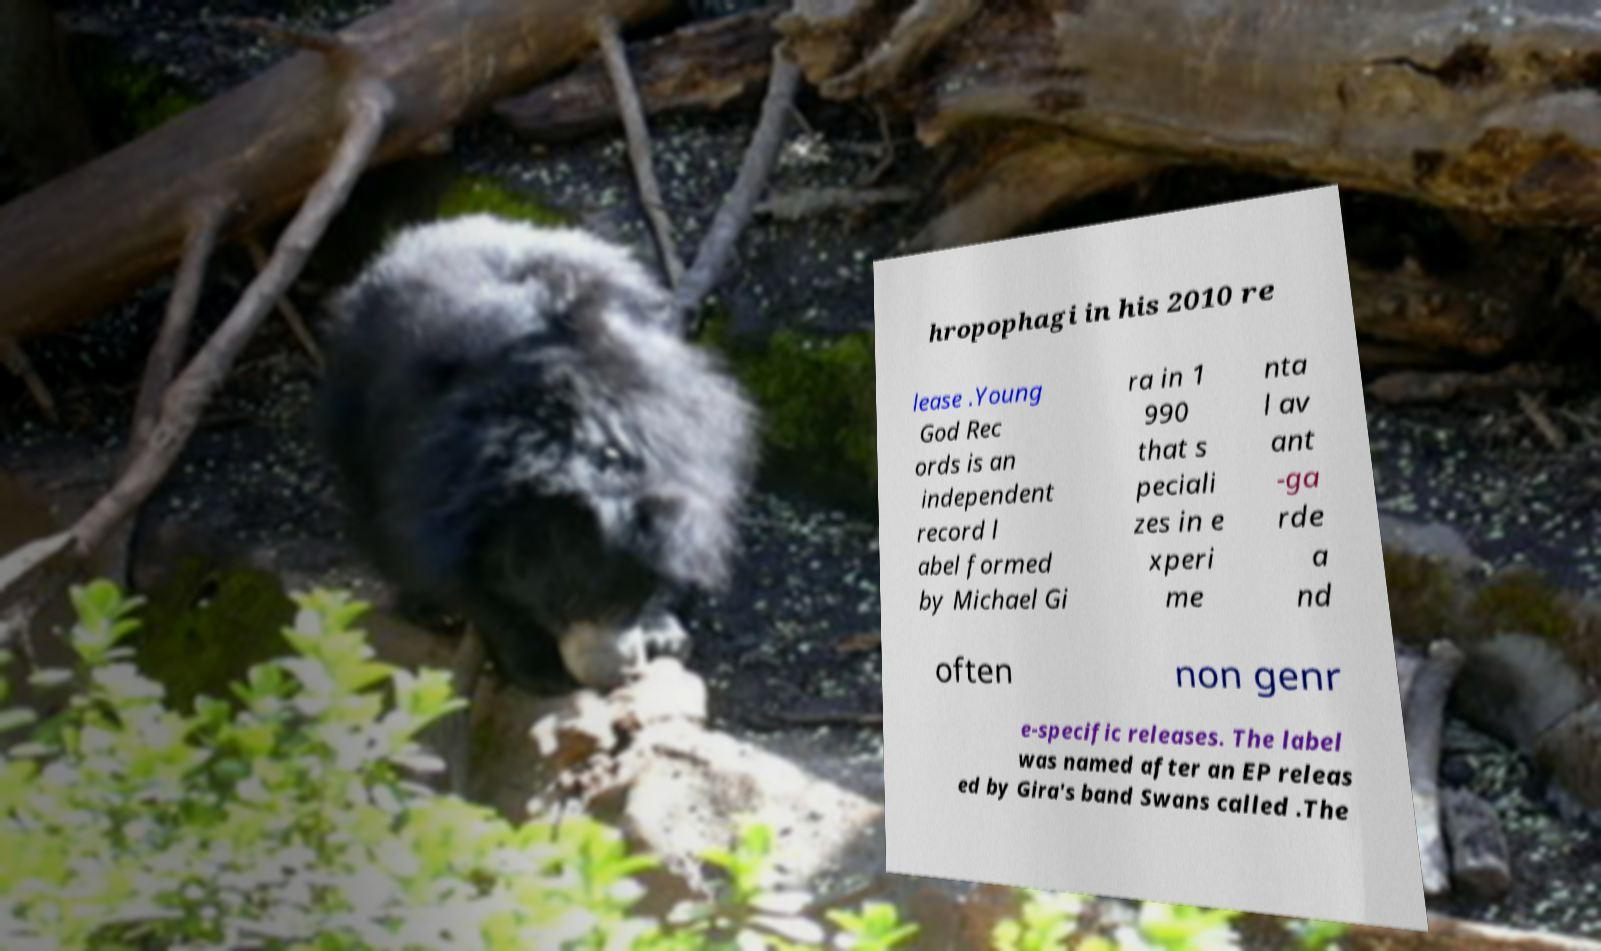Could you assist in decoding the text presented in this image and type it out clearly? hropophagi in his 2010 re lease .Young God Rec ords is an independent record l abel formed by Michael Gi ra in 1 990 that s peciali zes in e xperi me nta l av ant -ga rde a nd often non genr e-specific releases. The label was named after an EP releas ed by Gira's band Swans called .The 